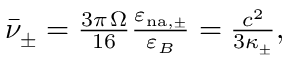Convert formula to latex. <formula><loc_0><loc_0><loc_500><loc_500>\begin{array} { r } { \bar { \nu } _ { \pm } = \frac { 3 \pi \, \Omega } { 1 6 } \frac { \varepsilon _ { n { a } , \pm } } { \varepsilon _ { B } } = \frac { c ^ { 2 } } { 3 \kappa _ { \pm } } , } \end{array}</formula> 